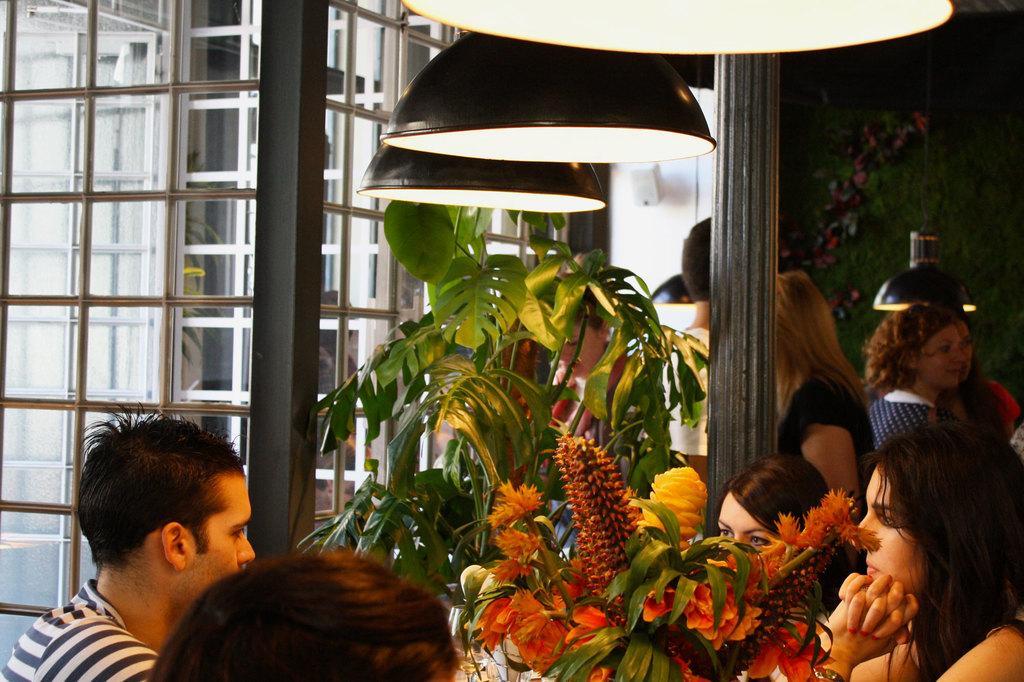Can you describe this image briefly? In this image we can see these people are sitting near the table where glasses and the flowertots kept. Here we can see the ceiling lights. In the background, we can see a few more people, we can see glass windows and this part of the image is dark. 